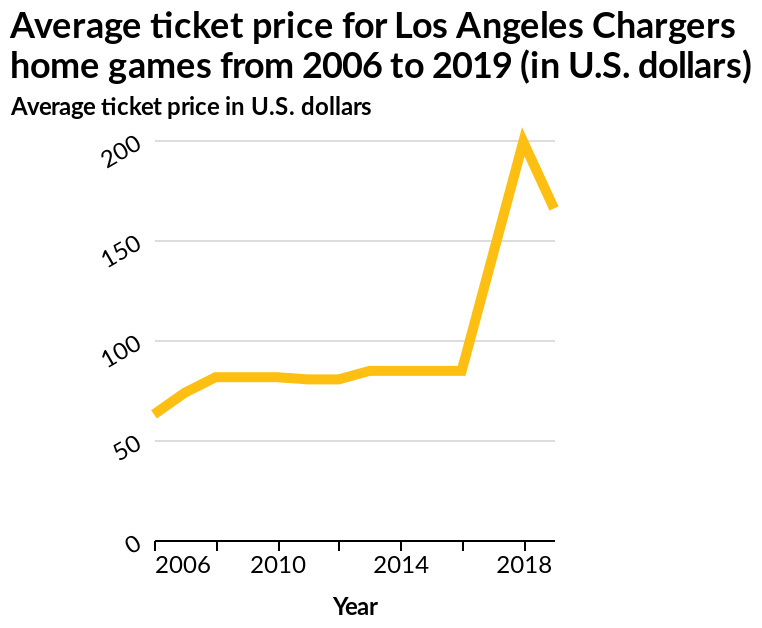<image>
In how many years did the average price of a ticket nearly quadruple? The average price of a ticket nearly quadrupled in two years. How did the average price of a ticket change after 2018? The average price of a ticket began to drop after 2018. What was the change in the average price of a ticket between 2006 and 2016? There was no significant change in the average price of a ticket between 2006 and 2016. please enumerates aspects of the construction of the chart Average ticket price for Los Angeles Chargers home games from 2006 to 2019 (in U.S. dollars) is a line chart. The x-axis plots Year while the y-axis shows Average ticket price in U.S. dollars. 